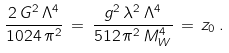<formula> <loc_0><loc_0><loc_500><loc_500>\frac { 2 \, G ^ { 2 } \, \Lambda ^ { 4 } } { 1 0 2 4 \, \pi ^ { 2 } } \, = \, \frac { g ^ { 2 } \, \lambda ^ { 2 } \, \Lambda ^ { 4 } } { 5 1 2 \, \pi ^ { 2 } \, M _ { W } ^ { 4 } } \, = \, z _ { 0 } \, .</formula> 